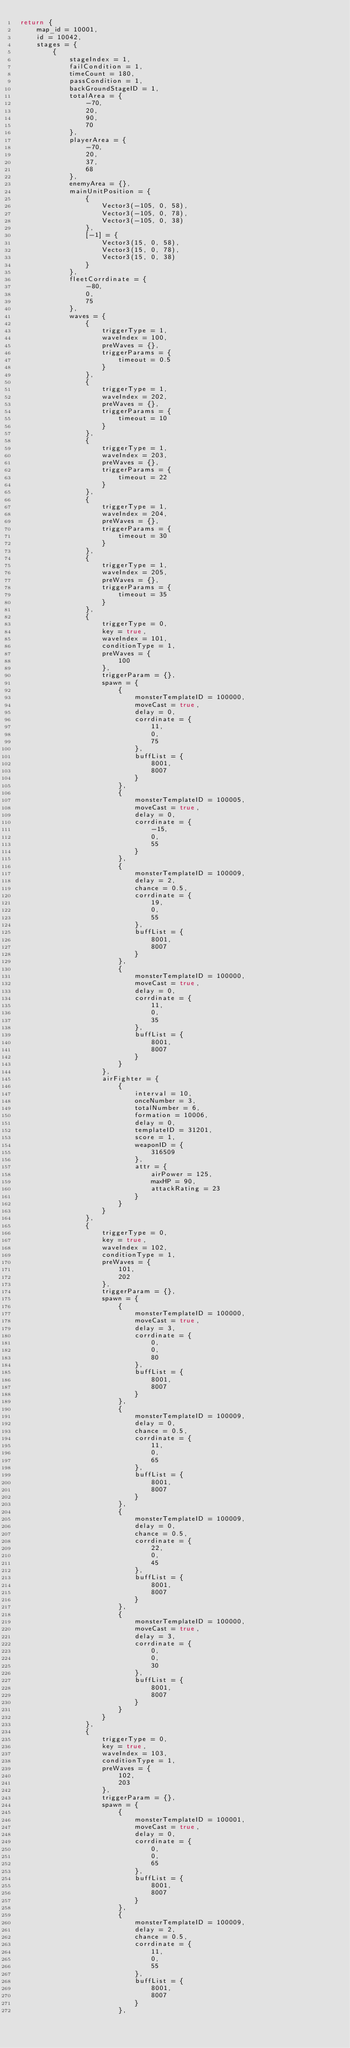Convert code to text. <code><loc_0><loc_0><loc_500><loc_500><_Lua_>return {
	map_id = 10001,
	id = 10042,
	stages = {
		{
			stageIndex = 1,
			failCondition = 1,
			timeCount = 180,
			passCondition = 1,
			backGroundStageID = 1,
			totalArea = {
				-70,
				20,
				90,
				70
			},
			playerArea = {
				-70,
				20,
				37,
				68
			},
			enemyArea = {},
			mainUnitPosition = {
				{
					Vector3(-105, 0, 58),
					Vector3(-105, 0, 78),
					Vector3(-105, 0, 38)
				},
				[-1] = {
					Vector3(15, 0, 58),
					Vector3(15, 0, 78),
					Vector3(15, 0, 38)
				}
			},
			fleetCorrdinate = {
				-80,
				0,
				75
			},
			waves = {
				{
					triggerType = 1,
					waveIndex = 100,
					preWaves = {},
					triggerParams = {
						timeout = 0.5
					}
				},
				{
					triggerType = 1,
					waveIndex = 202,
					preWaves = {},
					triggerParams = {
						timeout = 10
					}
				},
				{
					triggerType = 1,
					waveIndex = 203,
					preWaves = {},
					triggerParams = {
						timeout = 22
					}
				},
				{
					triggerType = 1,
					waveIndex = 204,
					preWaves = {},
					triggerParams = {
						timeout = 30
					}
				},
				{
					triggerType = 1,
					waveIndex = 205,
					preWaves = {},
					triggerParams = {
						timeout = 35
					}
				},
				{
					triggerType = 0,
					key = true,
					waveIndex = 101,
					conditionType = 1,
					preWaves = {
						100
					},
					triggerParam = {},
					spawn = {
						{
							monsterTemplateID = 100000,
							moveCast = true,
							delay = 0,
							corrdinate = {
								11,
								0,
								75
							},
							buffList = {
								8001,
								8007
							}
						},
						{
							monsterTemplateID = 100005,
							moveCast = true,
							delay = 0,
							corrdinate = {
								-15,
								0,
								55
							}
						},
						{
							monsterTemplateID = 100009,
							delay = 2,
							chance = 0.5,
							corrdinate = {
								19,
								0,
								55
							},
							buffList = {
								8001,
								8007
							}
						},
						{
							monsterTemplateID = 100000,
							moveCast = true,
							delay = 0,
							corrdinate = {
								11,
								0,
								35
							},
							buffList = {
								8001,
								8007
							}
						}
					},
					airFighter = {
						{
							interval = 10,
							onceNumber = 3,
							totalNumber = 6,
							formation = 10006,
							delay = 0,
							templateID = 31201,
							score = 1,
							weaponID = {
								316509
							},
							attr = {
								airPower = 125,
								maxHP = 90,
								attackRating = 23
							}
						}
					}
				},
				{
					triggerType = 0,
					key = true,
					waveIndex = 102,
					conditionType = 1,
					preWaves = {
						101,
						202
					},
					triggerParam = {},
					spawn = {
						{
							monsterTemplateID = 100000,
							moveCast = true,
							delay = 3,
							corrdinate = {
								0,
								0,
								80
							},
							buffList = {
								8001,
								8007
							}
						},
						{
							monsterTemplateID = 100009,
							delay = 0,
							chance = 0.5,
							corrdinate = {
								11,
								0,
								65
							},
							buffList = {
								8001,
								8007
							}
						},
						{
							monsterTemplateID = 100009,
							delay = 0,
							chance = 0.5,
							corrdinate = {
								22,
								0,
								45
							},
							buffList = {
								8001,
								8007
							}
						},
						{
							monsterTemplateID = 100000,
							moveCast = true,
							delay = 3,
							corrdinate = {
								0,
								0,
								30
							},
							buffList = {
								8001,
								8007
							}
						}
					}
				},
				{
					triggerType = 0,
					key = true,
					waveIndex = 103,
					conditionType = 1,
					preWaves = {
						102,
						203
					},
					triggerParam = {},
					spawn = {
						{
							monsterTemplateID = 100001,
							moveCast = true,
							delay = 0,
							corrdinate = {
								0,
								0,
								65
							},
							buffList = {
								8001,
								8007
							}
						},
						{
							monsterTemplateID = 100009,
							delay = 2,
							chance = 0.5,
							corrdinate = {
								11,
								0,
								55
							},
							buffList = {
								8001,
								8007
							}
						},</code> 